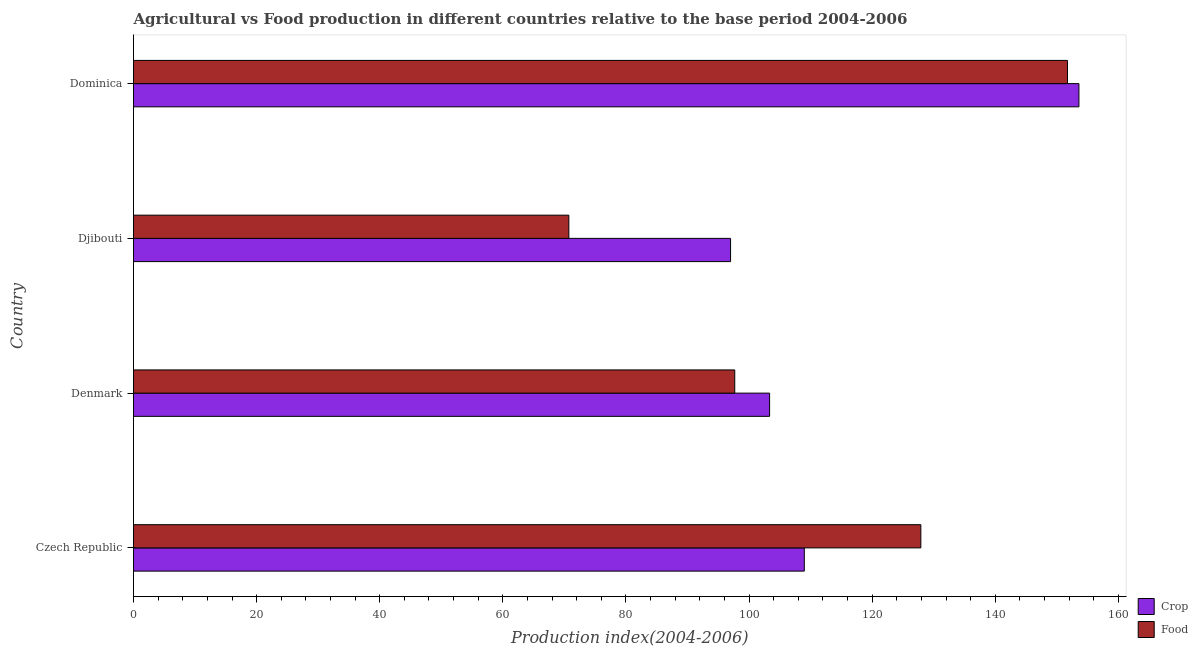Are the number of bars per tick equal to the number of legend labels?
Ensure brevity in your answer.  Yes. How many bars are there on the 3rd tick from the bottom?
Provide a succinct answer. 2. In how many cases, is the number of bars for a given country not equal to the number of legend labels?
Your answer should be compact. 0. What is the food production index in Denmark?
Offer a very short reply. 97.67. Across all countries, what is the maximum food production index?
Make the answer very short. 151.72. Across all countries, what is the minimum crop production index?
Give a very brief answer. 96.99. In which country was the food production index maximum?
Your answer should be very brief. Dominica. In which country was the food production index minimum?
Ensure brevity in your answer.  Djibouti. What is the total crop production index in the graph?
Make the answer very short. 462.87. What is the difference between the crop production index in Czech Republic and that in Dominica?
Give a very brief answer. -44.61. What is the difference between the food production index in Djibouti and the crop production index in Denmark?
Offer a very short reply. -32.61. What is the average crop production index per country?
Your response must be concise. 115.72. What is the difference between the food production index and crop production index in Dominica?
Provide a short and direct response. -1.86. In how many countries, is the crop production index greater than 136 ?
Ensure brevity in your answer.  1. What is the ratio of the food production index in Czech Republic to that in Djibouti?
Offer a terse response. 1.81. Is the crop production index in Denmark less than that in Dominica?
Your response must be concise. Yes. What is the difference between the highest and the second highest crop production index?
Ensure brevity in your answer.  44.61. In how many countries, is the food production index greater than the average food production index taken over all countries?
Ensure brevity in your answer.  2. What does the 1st bar from the top in Dominica represents?
Ensure brevity in your answer.  Food. What does the 1st bar from the bottom in Czech Republic represents?
Keep it short and to the point. Crop. How many bars are there?
Provide a short and direct response. 8. Are all the bars in the graph horizontal?
Your answer should be compact. Yes. What is the difference between two consecutive major ticks on the X-axis?
Give a very brief answer. 20. Are the values on the major ticks of X-axis written in scientific E-notation?
Offer a very short reply. No. How many legend labels are there?
Keep it short and to the point. 2. What is the title of the graph?
Offer a very short reply. Agricultural vs Food production in different countries relative to the base period 2004-2006. Does "GDP per capita" appear as one of the legend labels in the graph?
Keep it short and to the point. No. What is the label or title of the X-axis?
Provide a succinct answer. Production index(2004-2006). What is the Production index(2004-2006) of Crop in Czech Republic?
Make the answer very short. 108.97. What is the Production index(2004-2006) in Food in Czech Republic?
Offer a very short reply. 127.9. What is the Production index(2004-2006) in Crop in Denmark?
Keep it short and to the point. 103.33. What is the Production index(2004-2006) of Food in Denmark?
Your response must be concise. 97.67. What is the Production index(2004-2006) of Crop in Djibouti?
Your answer should be very brief. 96.99. What is the Production index(2004-2006) of Food in Djibouti?
Keep it short and to the point. 70.72. What is the Production index(2004-2006) of Crop in Dominica?
Ensure brevity in your answer.  153.58. What is the Production index(2004-2006) in Food in Dominica?
Your answer should be compact. 151.72. Across all countries, what is the maximum Production index(2004-2006) of Crop?
Your answer should be compact. 153.58. Across all countries, what is the maximum Production index(2004-2006) in Food?
Make the answer very short. 151.72. Across all countries, what is the minimum Production index(2004-2006) in Crop?
Offer a very short reply. 96.99. Across all countries, what is the minimum Production index(2004-2006) of Food?
Your response must be concise. 70.72. What is the total Production index(2004-2006) of Crop in the graph?
Make the answer very short. 462.87. What is the total Production index(2004-2006) of Food in the graph?
Offer a terse response. 448.01. What is the difference between the Production index(2004-2006) in Crop in Czech Republic and that in Denmark?
Offer a very short reply. 5.64. What is the difference between the Production index(2004-2006) of Food in Czech Republic and that in Denmark?
Keep it short and to the point. 30.23. What is the difference between the Production index(2004-2006) in Crop in Czech Republic and that in Djibouti?
Ensure brevity in your answer.  11.98. What is the difference between the Production index(2004-2006) in Food in Czech Republic and that in Djibouti?
Offer a very short reply. 57.18. What is the difference between the Production index(2004-2006) of Crop in Czech Republic and that in Dominica?
Give a very brief answer. -44.61. What is the difference between the Production index(2004-2006) in Food in Czech Republic and that in Dominica?
Give a very brief answer. -23.82. What is the difference between the Production index(2004-2006) of Crop in Denmark and that in Djibouti?
Keep it short and to the point. 6.34. What is the difference between the Production index(2004-2006) of Food in Denmark and that in Djibouti?
Your answer should be compact. 26.95. What is the difference between the Production index(2004-2006) of Crop in Denmark and that in Dominica?
Provide a succinct answer. -50.25. What is the difference between the Production index(2004-2006) of Food in Denmark and that in Dominica?
Offer a very short reply. -54.05. What is the difference between the Production index(2004-2006) of Crop in Djibouti and that in Dominica?
Offer a terse response. -56.59. What is the difference between the Production index(2004-2006) in Food in Djibouti and that in Dominica?
Ensure brevity in your answer.  -81. What is the difference between the Production index(2004-2006) of Crop in Czech Republic and the Production index(2004-2006) of Food in Djibouti?
Provide a succinct answer. 38.25. What is the difference between the Production index(2004-2006) in Crop in Czech Republic and the Production index(2004-2006) in Food in Dominica?
Make the answer very short. -42.75. What is the difference between the Production index(2004-2006) of Crop in Denmark and the Production index(2004-2006) of Food in Djibouti?
Provide a succinct answer. 32.61. What is the difference between the Production index(2004-2006) of Crop in Denmark and the Production index(2004-2006) of Food in Dominica?
Offer a very short reply. -48.39. What is the difference between the Production index(2004-2006) in Crop in Djibouti and the Production index(2004-2006) in Food in Dominica?
Ensure brevity in your answer.  -54.73. What is the average Production index(2004-2006) of Crop per country?
Provide a succinct answer. 115.72. What is the average Production index(2004-2006) of Food per country?
Give a very brief answer. 112. What is the difference between the Production index(2004-2006) of Crop and Production index(2004-2006) of Food in Czech Republic?
Your answer should be compact. -18.93. What is the difference between the Production index(2004-2006) in Crop and Production index(2004-2006) in Food in Denmark?
Keep it short and to the point. 5.66. What is the difference between the Production index(2004-2006) in Crop and Production index(2004-2006) in Food in Djibouti?
Keep it short and to the point. 26.27. What is the difference between the Production index(2004-2006) of Crop and Production index(2004-2006) of Food in Dominica?
Make the answer very short. 1.86. What is the ratio of the Production index(2004-2006) of Crop in Czech Republic to that in Denmark?
Offer a terse response. 1.05. What is the ratio of the Production index(2004-2006) in Food in Czech Republic to that in Denmark?
Your answer should be very brief. 1.31. What is the ratio of the Production index(2004-2006) in Crop in Czech Republic to that in Djibouti?
Your answer should be compact. 1.12. What is the ratio of the Production index(2004-2006) in Food in Czech Republic to that in Djibouti?
Keep it short and to the point. 1.81. What is the ratio of the Production index(2004-2006) of Crop in Czech Republic to that in Dominica?
Offer a terse response. 0.71. What is the ratio of the Production index(2004-2006) in Food in Czech Republic to that in Dominica?
Your answer should be very brief. 0.84. What is the ratio of the Production index(2004-2006) in Crop in Denmark to that in Djibouti?
Make the answer very short. 1.07. What is the ratio of the Production index(2004-2006) in Food in Denmark to that in Djibouti?
Keep it short and to the point. 1.38. What is the ratio of the Production index(2004-2006) of Crop in Denmark to that in Dominica?
Give a very brief answer. 0.67. What is the ratio of the Production index(2004-2006) of Food in Denmark to that in Dominica?
Your answer should be compact. 0.64. What is the ratio of the Production index(2004-2006) of Crop in Djibouti to that in Dominica?
Offer a terse response. 0.63. What is the ratio of the Production index(2004-2006) in Food in Djibouti to that in Dominica?
Offer a very short reply. 0.47. What is the difference between the highest and the second highest Production index(2004-2006) of Crop?
Give a very brief answer. 44.61. What is the difference between the highest and the second highest Production index(2004-2006) in Food?
Provide a short and direct response. 23.82. What is the difference between the highest and the lowest Production index(2004-2006) of Crop?
Ensure brevity in your answer.  56.59. 